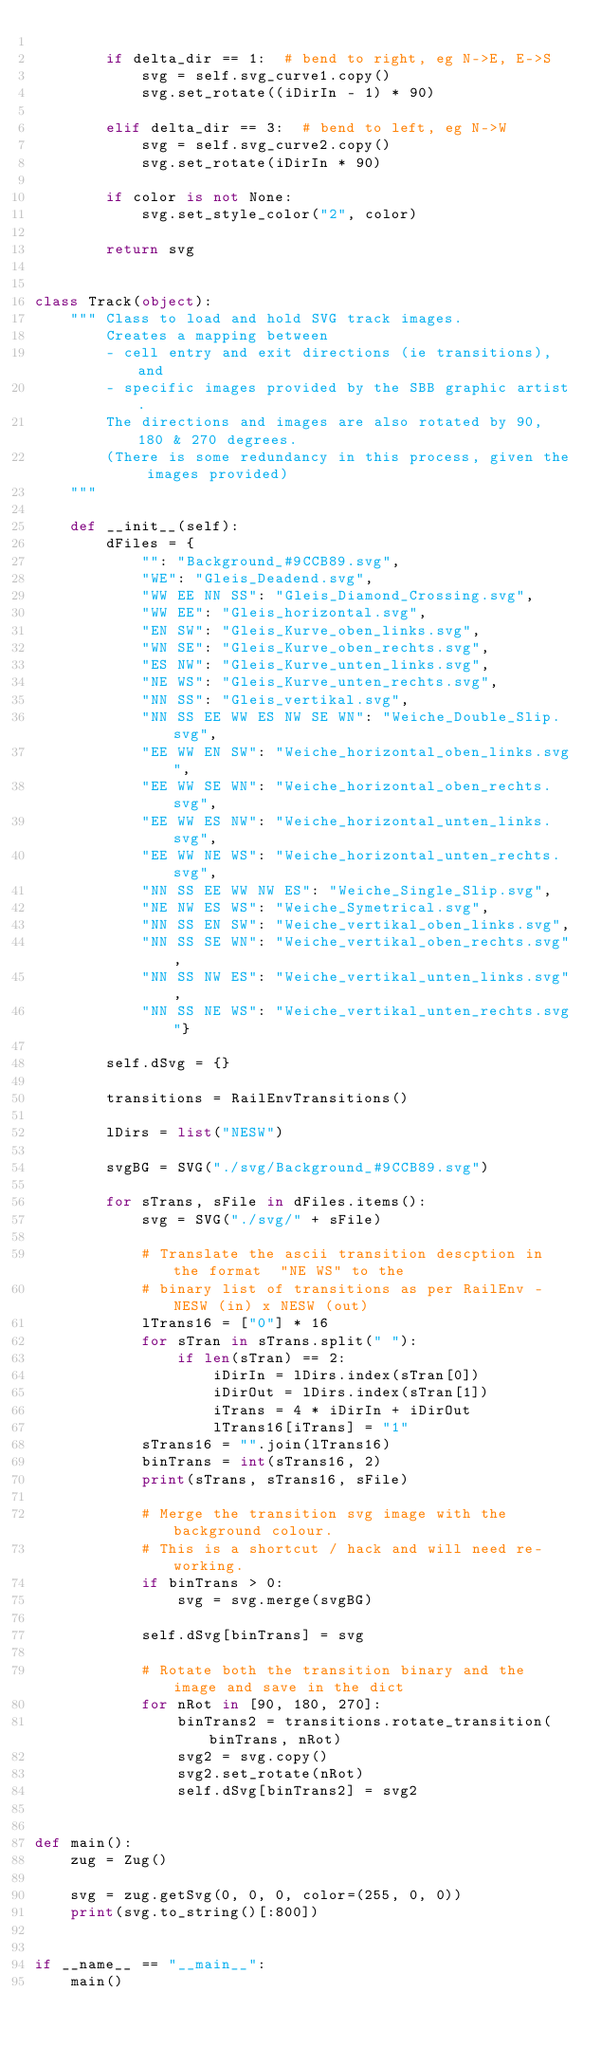Convert code to text. <code><loc_0><loc_0><loc_500><loc_500><_Python_>
        if delta_dir == 1:  # bend to right, eg N->E, E->S
            svg = self.svg_curve1.copy()
            svg.set_rotate((iDirIn - 1) * 90)

        elif delta_dir == 3:  # bend to left, eg N->W
            svg = self.svg_curve2.copy()
            svg.set_rotate(iDirIn * 90)

        if color is not None:
            svg.set_style_color("2", color)

        return svg


class Track(object):
    """ Class to load and hold SVG track images.
        Creates a mapping between
        - cell entry and exit directions (ie transitions), and
        - specific images provided by the SBB graphic artist.
        The directions and images are also rotated by 90, 180 & 270 degrees.
        (There is some redundancy in this process, given the images provided)
    """

    def __init__(self):
        dFiles = {
            "": "Background_#9CCB89.svg",
            "WE": "Gleis_Deadend.svg",
            "WW EE NN SS": "Gleis_Diamond_Crossing.svg",
            "WW EE": "Gleis_horizontal.svg",
            "EN SW": "Gleis_Kurve_oben_links.svg",
            "WN SE": "Gleis_Kurve_oben_rechts.svg",
            "ES NW": "Gleis_Kurve_unten_links.svg",
            "NE WS": "Gleis_Kurve_unten_rechts.svg",
            "NN SS": "Gleis_vertikal.svg",
            "NN SS EE WW ES NW SE WN": "Weiche_Double_Slip.svg",
            "EE WW EN SW": "Weiche_horizontal_oben_links.svg",
            "EE WW SE WN": "Weiche_horizontal_oben_rechts.svg",
            "EE WW ES NW": "Weiche_horizontal_unten_links.svg",
            "EE WW NE WS": "Weiche_horizontal_unten_rechts.svg",
            "NN SS EE WW NW ES": "Weiche_Single_Slip.svg",
            "NE NW ES WS": "Weiche_Symetrical.svg",
            "NN SS EN SW": "Weiche_vertikal_oben_links.svg",
            "NN SS SE WN": "Weiche_vertikal_oben_rechts.svg",
            "NN SS NW ES": "Weiche_vertikal_unten_links.svg",
            "NN SS NE WS": "Weiche_vertikal_unten_rechts.svg"}

        self.dSvg = {}

        transitions = RailEnvTransitions()

        lDirs = list("NESW")

        svgBG = SVG("./svg/Background_#9CCB89.svg")

        for sTrans, sFile in dFiles.items():
            svg = SVG("./svg/" + sFile)

            # Translate the ascii transition descption in the format  "NE WS" to the 
            # binary list of transitions as per RailEnv - NESW (in) x NESW (out)
            lTrans16 = ["0"] * 16
            for sTran in sTrans.split(" "):
                if len(sTran) == 2:
                    iDirIn = lDirs.index(sTran[0])
                    iDirOut = lDirs.index(sTran[1])
                    iTrans = 4 * iDirIn + iDirOut
                    lTrans16[iTrans] = "1"
            sTrans16 = "".join(lTrans16)
            binTrans = int(sTrans16, 2)
            print(sTrans, sTrans16, sFile)

            # Merge the transition svg image with the background colour.
            # This is a shortcut / hack and will need re-working.
            if binTrans > 0:
                svg = svg.merge(svgBG)

            self.dSvg[binTrans] = svg

            # Rotate both the transition binary and the image and save in the dict
            for nRot in [90, 180, 270]:
                binTrans2 = transitions.rotate_transition(binTrans, nRot)
                svg2 = svg.copy()
                svg2.set_rotate(nRot)
                self.dSvg[binTrans2] = svg2


def main():
    zug = Zug()

    svg = zug.getSvg(0, 0, 0, color=(255, 0, 0))
    print(svg.to_string()[:800])


if __name__ == "__main__":
    main()
</code> 